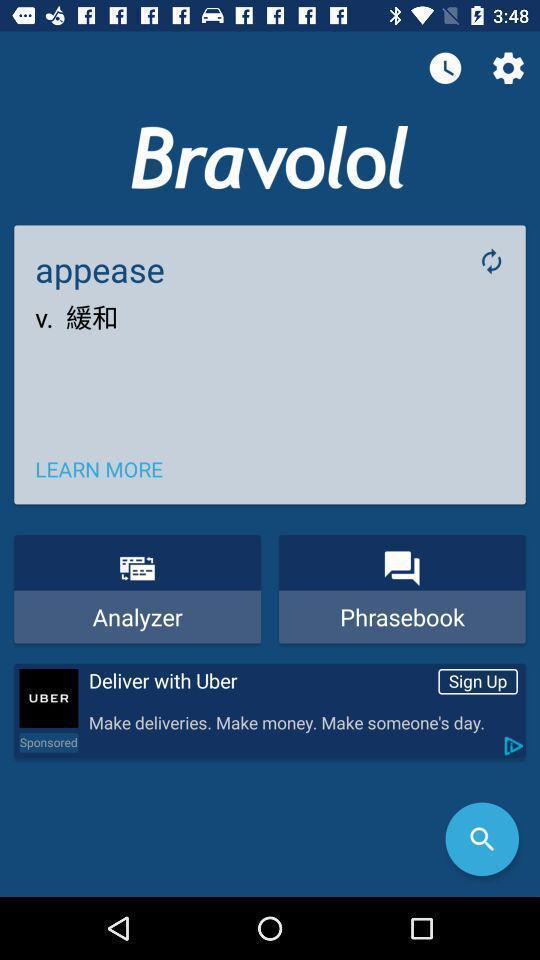What details can you identify in this image? Page showing translation details of dictionary and translator app. 